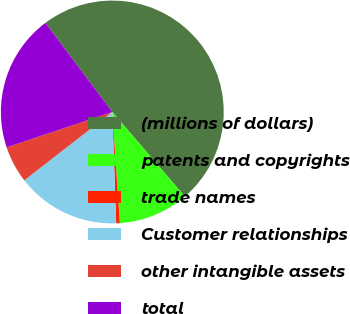<chart> <loc_0><loc_0><loc_500><loc_500><pie_chart><fcel>(millions of dollars)<fcel>patents and copyrights<fcel>trade names<fcel>Customer relationships<fcel>other intangible assets<fcel>total<nl><fcel>48.97%<fcel>10.21%<fcel>0.52%<fcel>15.05%<fcel>5.36%<fcel>19.9%<nl></chart> 